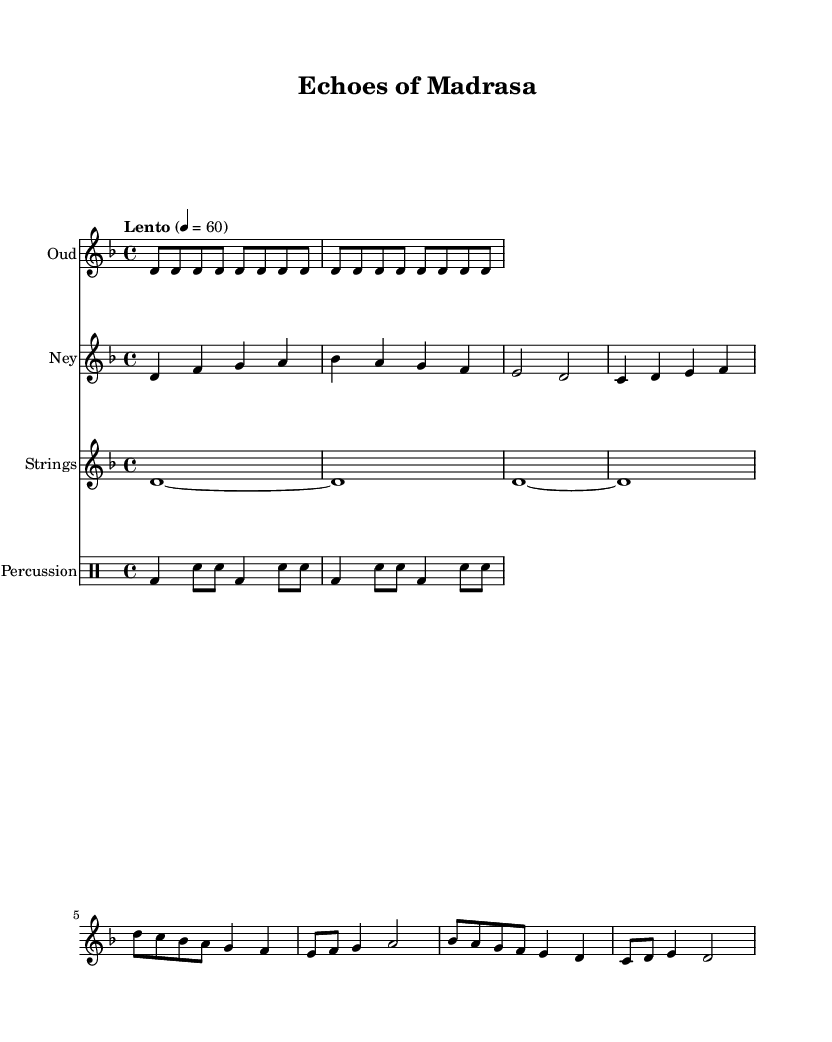What is the key signature of this music? The key signature is D minor, which has one flat (B flat). This is determined from the key signature symbol found at the beginning of the staff.
Answer: D minor What is the time signature of this music? The time signature is 4/4, which indicates four beats per measure and a quarter note receives one beat. This can be observed next to the clef at the beginning of the score.
Answer: 4/4 What is the tempo marking of the piece? The tempo marking states "Lento," which typically indicates a slow tempo. This is indicated at the start of the score above the staff.
Answer: Lento How many times is the Oud repeated? The Oud section is repeated 2 times, which can be seen in the repeat sign that appears after the first phrase of the Oud part.
Answer: 2 What instruments are featured in this score? The instruments featured are Oud, Ney, Strings, and Percussion. This is indicated in the headers of each staff at the beginning of each part.
Answer: Oud, Ney, Strings, Percussion What is the first note played by the Ney? The first note played by the Ney is D. This can be identified as it is the first note in the Ney section written immediately after the staff's header.
Answer: D How many measures are in the percussion part? There are 4 measures in the percussion part, which can be counted by looking at how many sets of vertical lines separate the notes in the percussion staff.
Answer: 4 